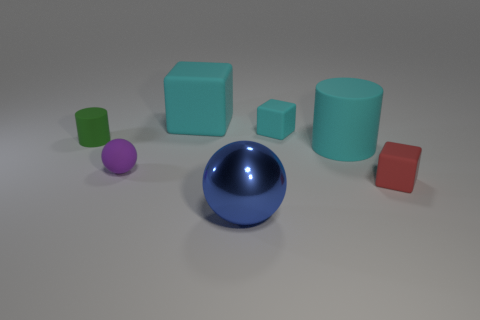How many objects are there in total, and can you describe them by color and shape? There are seven objects in total. Starting from the largest, there's a glossy blue sphere, a matte teal cube, and a glossy teal cylinder. There's also a small glossy red cube, a small matte green cylinder, a small matte purple sphere, and a tiny glossy green cube. 